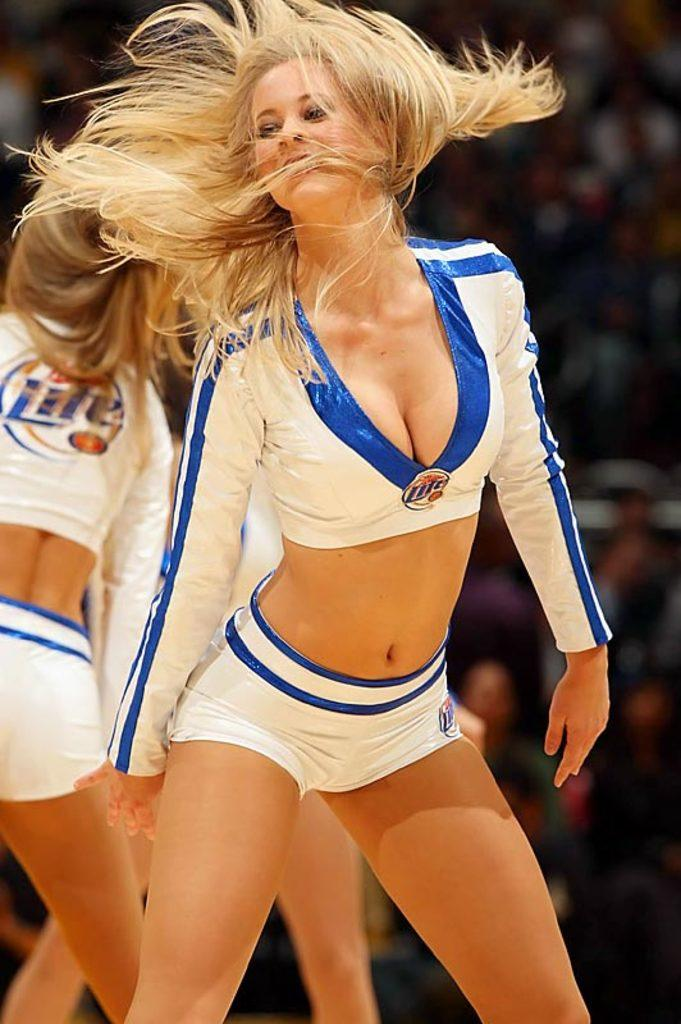<image>
Offer a succinct explanation of the picture presented. Cheerleaders wearing Miller Lite on their uniform perform at a game. 